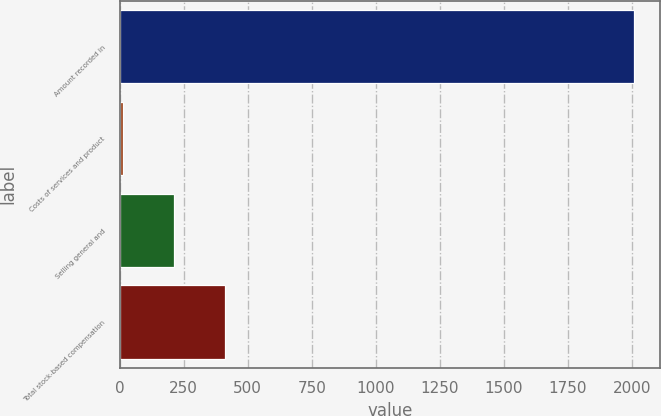<chart> <loc_0><loc_0><loc_500><loc_500><bar_chart><fcel>Amount recorded in<fcel>Costs of services and product<fcel>Selling general and<fcel>Total stock-based compensation<nl><fcel>2009<fcel>12.6<fcel>212.24<fcel>411.88<nl></chart> 